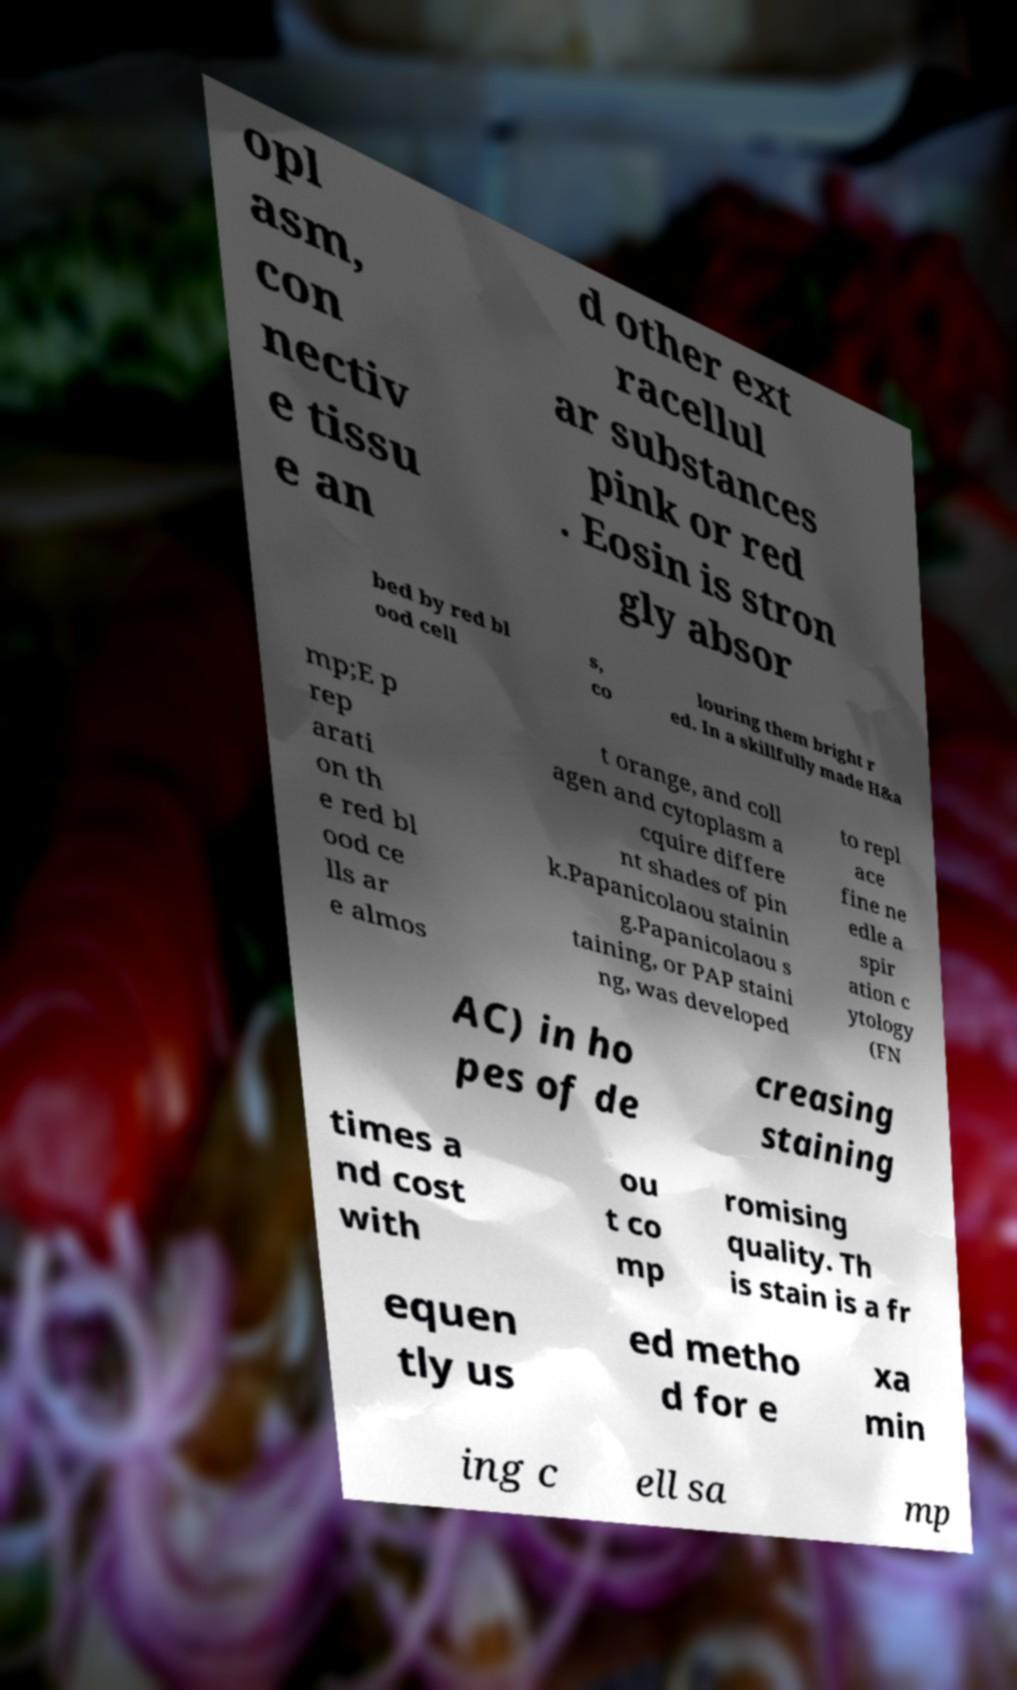Could you assist in decoding the text presented in this image and type it out clearly? opl asm, con nectiv e tissu e an d other ext racellul ar substances pink or red . Eosin is stron gly absor bed by red bl ood cell s, co louring them bright r ed. In a skillfully made H&a mp;E p rep arati on th e red bl ood ce lls ar e almos t orange, and coll agen and cytoplasm a cquire differe nt shades of pin k.Papanicolaou stainin g.Papanicolaou s taining, or PAP staini ng, was developed to repl ace fine ne edle a spir ation c ytology (FN AC) in ho pes of de creasing staining times a nd cost with ou t co mp romising quality. Th is stain is a fr equen tly us ed metho d for e xa min ing c ell sa mp 